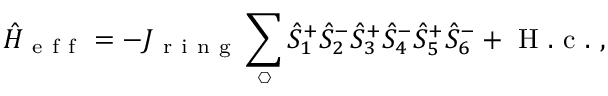Convert formula to latex. <formula><loc_0><loc_0><loc_500><loc_500>\hat { H } _ { e f f } = - J _ { r i n g } \sum _ { \ h e x a g o n } \hat { S } _ { 1 } ^ { + } \hat { S } _ { 2 } ^ { - } \hat { S } _ { 3 } ^ { + } \hat { S } _ { 4 } ^ { - } \hat { S } _ { 5 } ^ { + } \hat { S } _ { 6 } ^ { - } + H . c . ,</formula> 